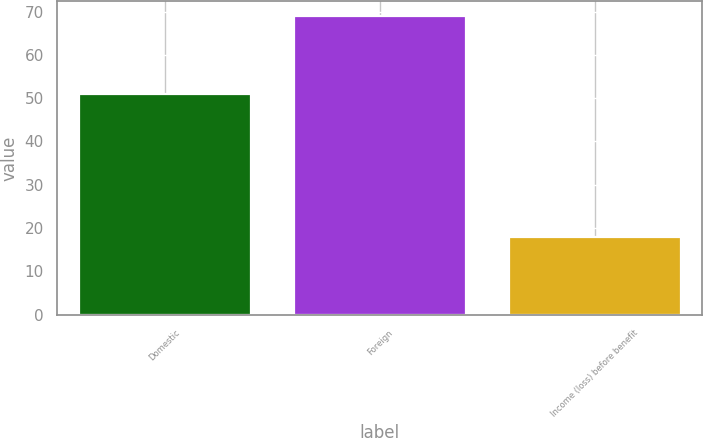<chart> <loc_0><loc_0><loc_500><loc_500><bar_chart><fcel>Domestic<fcel>Foreign<fcel>Income (loss) before benefit<nl><fcel>51<fcel>69<fcel>18<nl></chart> 